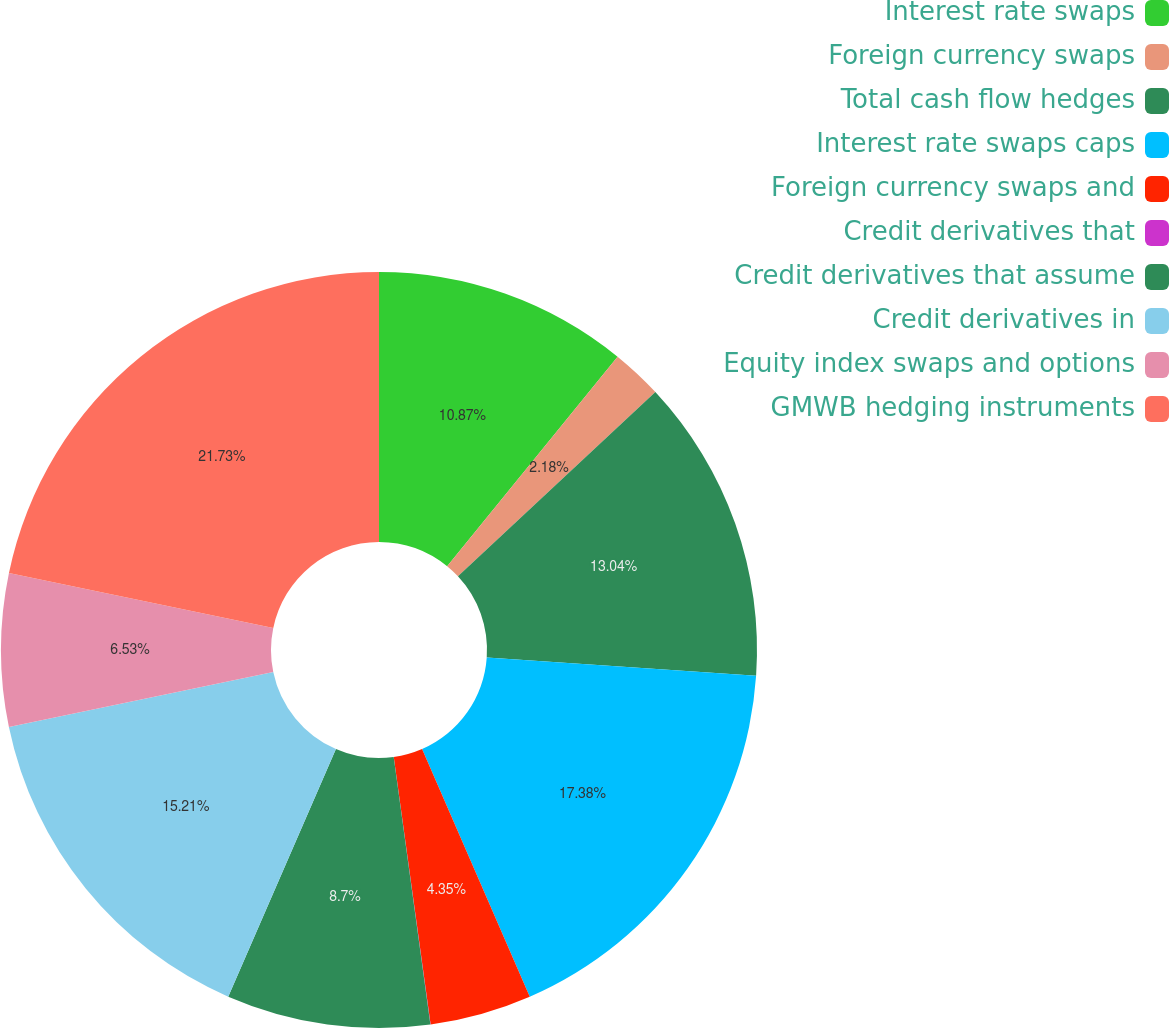Convert chart to OTSL. <chart><loc_0><loc_0><loc_500><loc_500><pie_chart><fcel>Interest rate swaps<fcel>Foreign currency swaps<fcel>Total cash flow hedges<fcel>Interest rate swaps caps<fcel>Foreign currency swaps and<fcel>Credit derivatives that<fcel>Credit derivatives that assume<fcel>Credit derivatives in<fcel>Equity index swaps and options<fcel>GMWB hedging instruments<nl><fcel>10.87%<fcel>2.18%<fcel>13.04%<fcel>17.38%<fcel>4.35%<fcel>0.01%<fcel>8.7%<fcel>15.21%<fcel>6.53%<fcel>21.73%<nl></chart> 